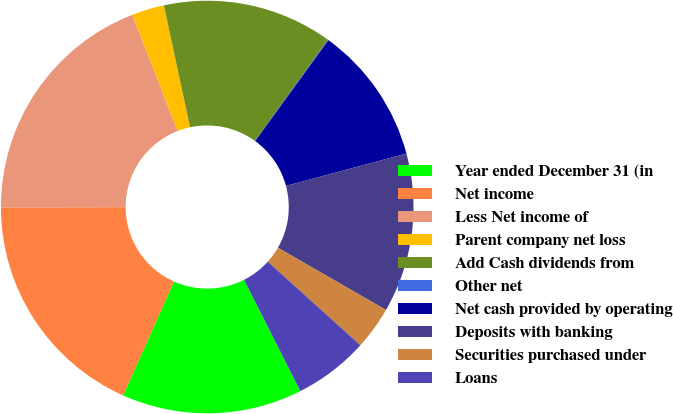<chart> <loc_0><loc_0><loc_500><loc_500><pie_chart><fcel>Year ended December 31 (in<fcel>Net income<fcel>Less Net income of<fcel>Parent company net loss<fcel>Add Cash dividends from<fcel>Other net<fcel>Net cash provided by operating<fcel>Deposits with banking<fcel>Securities purchased under<fcel>Loans<nl><fcel>14.14%<fcel>18.29%<fcel>19.12%<fcel>2.54%<fcel>13.32%<fcel>0.05%<fcel>10.83%<fcel>12.49%<fcel>3.37%<fcel>5.86%<nl></chart> 